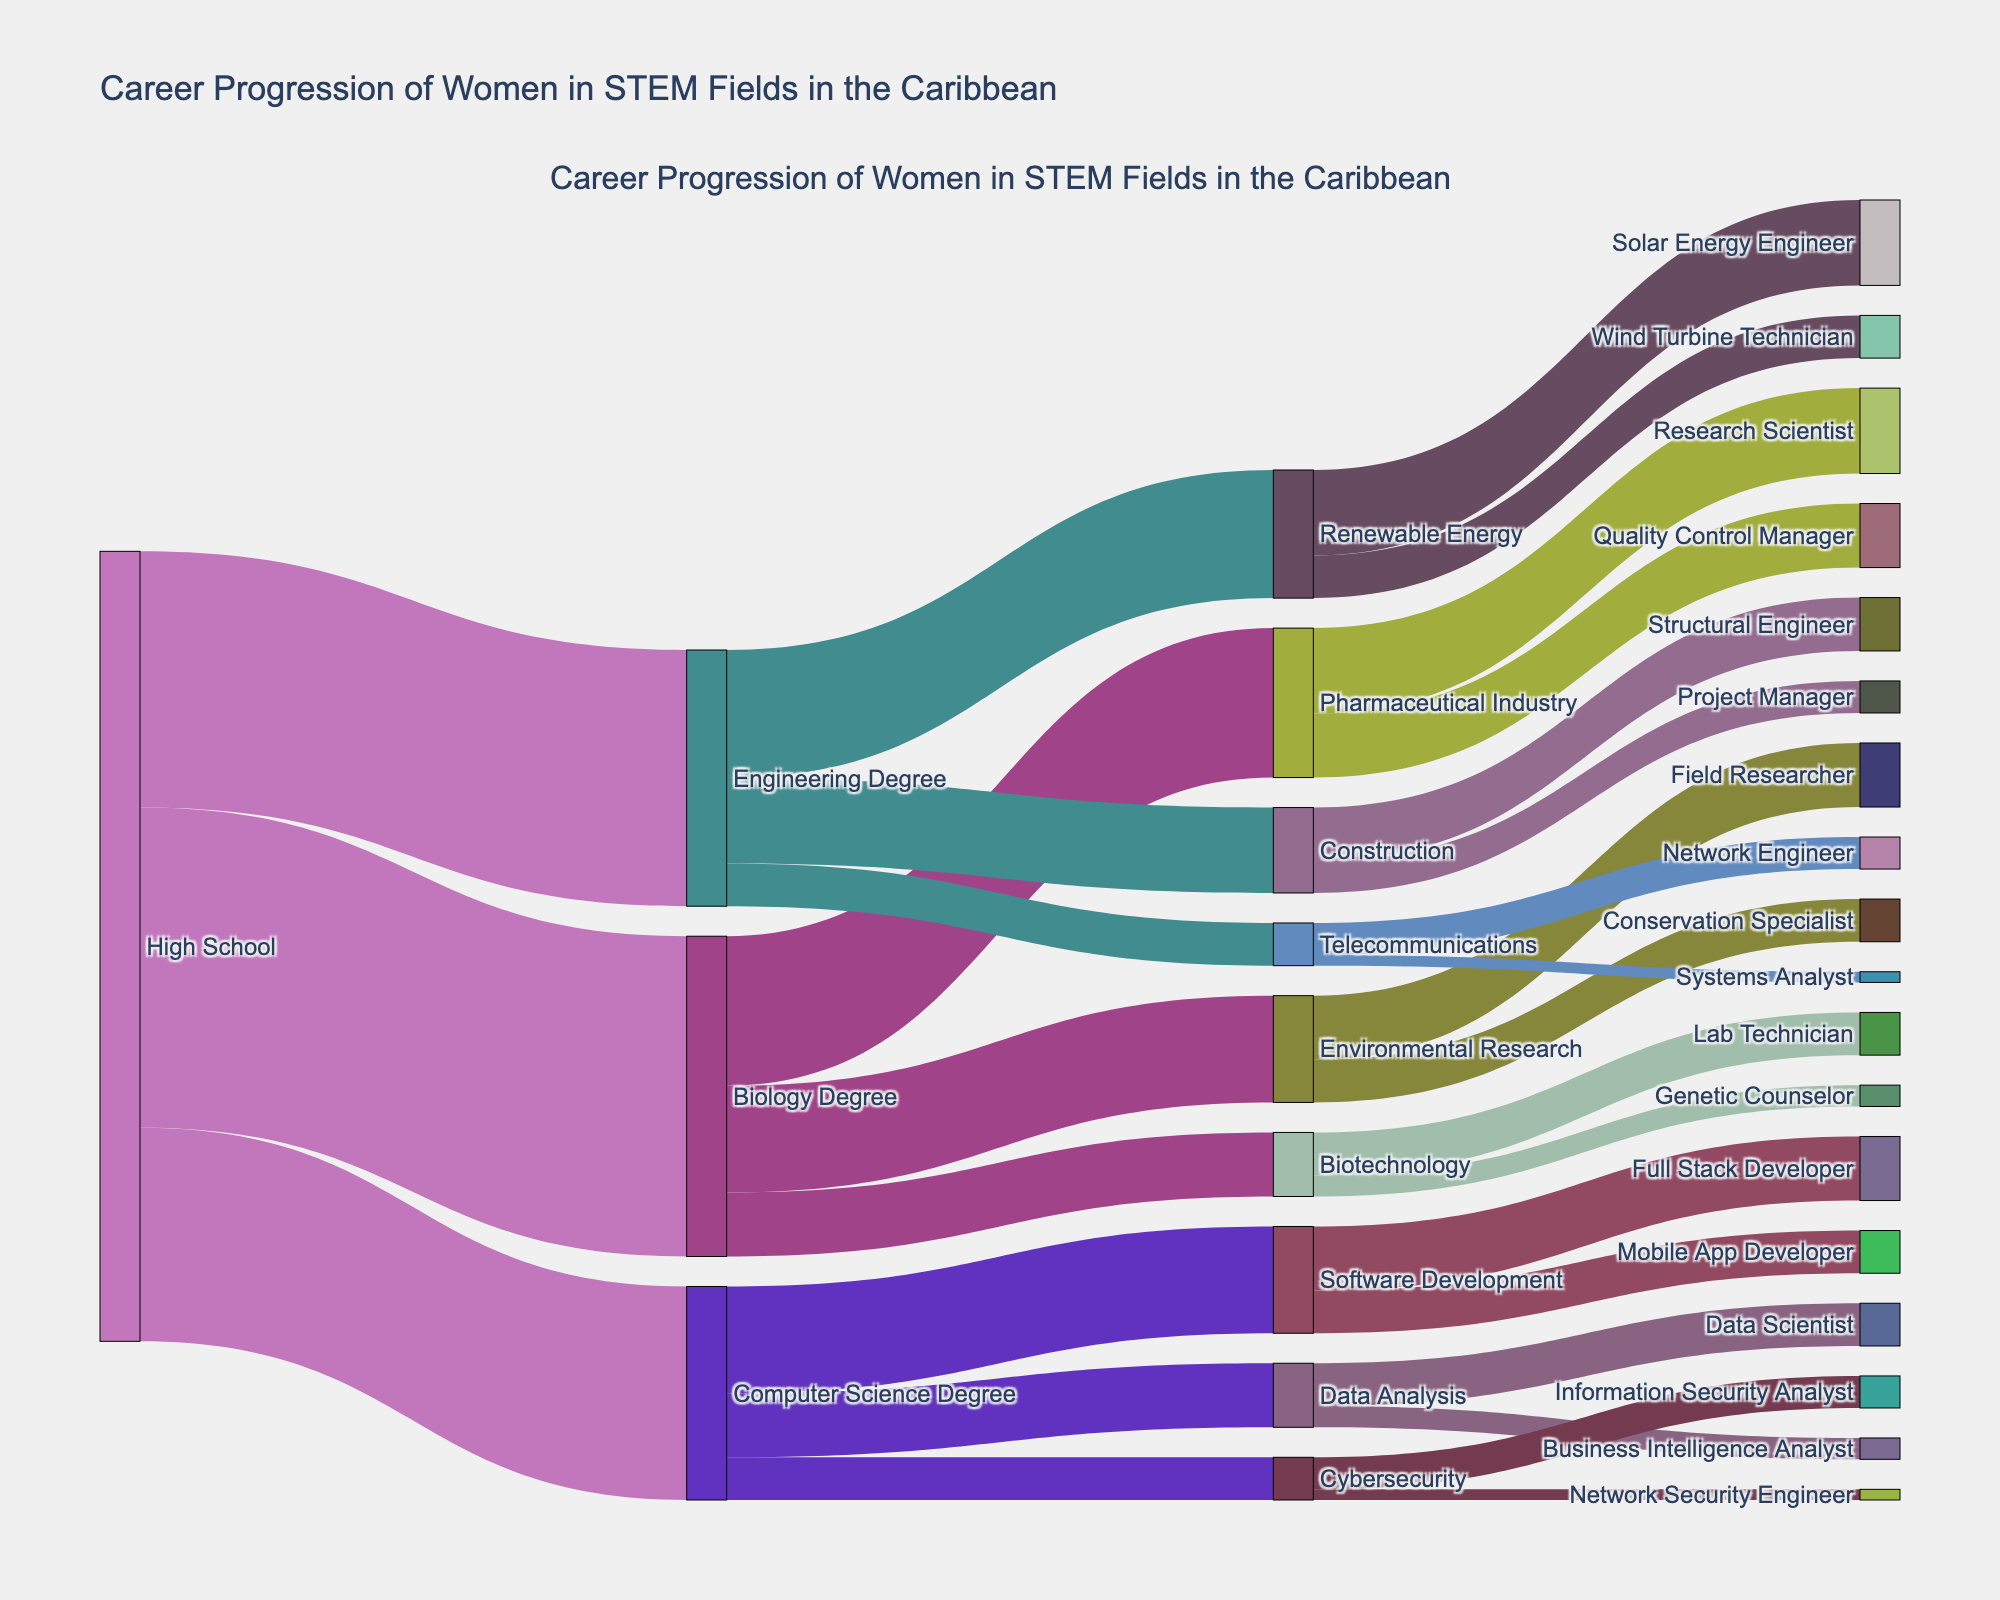What is the title of the figure? The title is usually displayed at the top center of the figure. By reading it directly, one can determine the main subject of the diagram.
Answer: Career Progression of Women in STEM Fields in the Caribbean How many transitions are there from a high school level to a Computer Science degree? By examining the part of the diagram that connects high school to various degrees, count how many transitions lead to a Computer Science degree.
Answer: 100 Which role has the highest number of women coming from a Biology Degree? Look at the segments that connect Biology Degree to different roles. The highest value connected segment indicates the role with the most women.
Answer: Pharmaceutical Industry How many women progressed into roles within Telecommunications from an Engineering Degree? Check the transitions from Engineering Degree to roles within Telecommunications, summing the values of those transitions.
Answer: 20 Summarize the total number of women entering STEM fields directly from high school. Add up all values connecting high school to different STEM degree programs.
Answer: 370 How many women move from the Pharmaceutical Industry to becoming Research Scientists and Quality Control Managers combined? Sum up the values for the transitions from Pharmaceutical Industry to Research Scientist and Quality Control Manager.
Answer: 70 Compare the number of women entering the Renewable Energy sector versus those entering Software Development from degree programs. Which one has more? Add the transitions into Renewable Energy roles and compare with the sum of transitions into Software Development roles.
Answer: Renewable Energy has 60; Software Development has 50 What is the least common career outcome for women with a degree in Biotechnology? Identify the role from Biotechnology with the smallest transition value.
Answer: Genetic Counselor From the Environmental Research field, what role has fewer women: Field Researcher or Conservation Specialist? Compare the values of transitions from Environmental Research to Field Researcher and Conservation Specialist.
Answer: Conservation Specialist What proportion of women with a Computer Science Degree moved into Software Development? Divide the number of transitions from Computer Science Degree to Software Development by the total number of women with a Computer Science Degree, and multiply by 100 to get the percentage.
Answer: 50% Which role in Telecommunications has fewer women, Network Engineer or Systems Analyst? By examining transitions from Telecommunications to each role, determine which segment is smaller.
Answer: Systems Analyst 